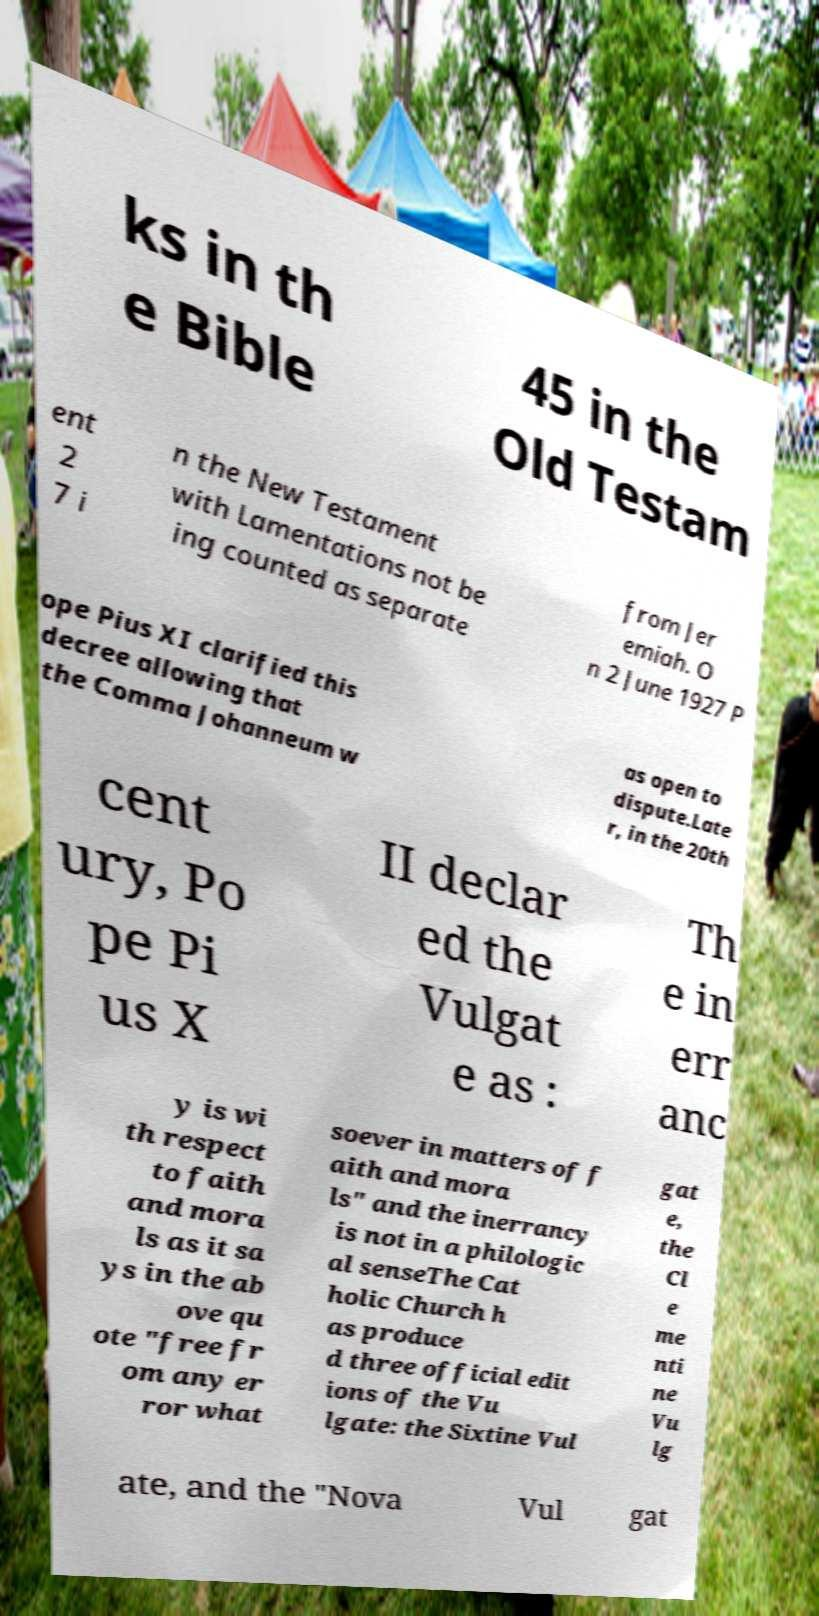I need the written content from this picture converted into text. Can you do that? ks in th e Bible 45 in the Old Testam ent 2 7 i n the New Testament with Lamentations not be ing counted as separate from Jer emiah. O n 2 June 1927 P ope Pius XI clarified this decree allowing that the Comma Johanneum w as open to dispute.Late r, in the 20th cent ury, Po pe Pi us X II declar ed the Vulgat e as : Th e in err anc y is wi th respect to faith and mora ls as it sa ys in the ab ove qu ote "free fr om any er ror what soever in matters of f aith and mora ls" and the inerrancy is not in a philologic al senseThe Cat holic Church h as produce d three official edit ions of the Vu lgate: the Sixtine Vul gat e, the Cl e me nti ne Vu lg ate, and the "Nova Vul gat 